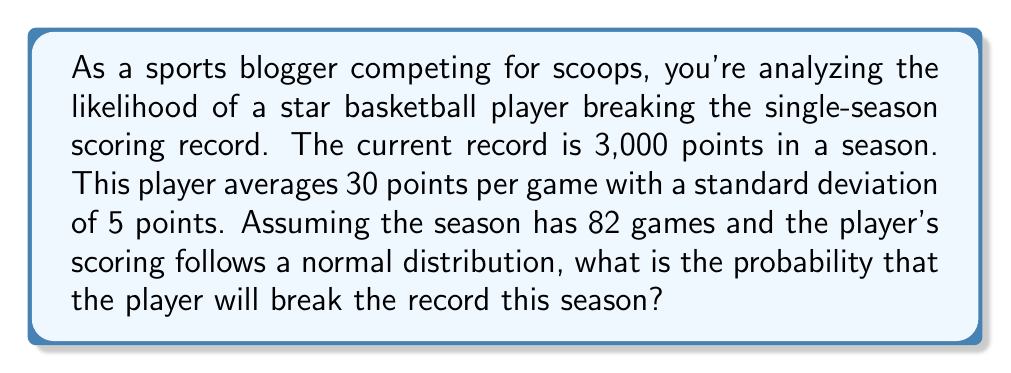Could you help me with this problem? To solve this problem, we need to follow these steps:

1) First, calculate the total points needed to break the record:
   3,000 + 1 = 3,001 points

2) Calculate the mean total points for the season:
   $\mu = 30 \text{ points/game} \times 82 \text{ games} = 2,460 \text{ points}$

3) Calculate the standard deviation for the season:
   $\sigma = 5 \text{ points/game} \times \sqrt{82 \text{ games}} = 45.28 \text{ points}$

4) Calculate the z-score for breaking the record:
   $$z = \frac{x - \mu}{\sigma} = \frac{3001 - 2460}{45.28} = 11.95$$

5) The probability of breaking the record is the area to the right of this z-score on a standard normal distribution.

6) We can use the compliment of the cumulative standard normal distribution function:
   $$P(X > 3001) = 1 - \Phi(11.95)$$

   Where $\Phi$ is the cumulative standard normal distribution function.

7) Using a standard normal table or calculator:
   $$1 - \Phi(11.95) \approx 1 - 0.999999999999 = 1 \times 10^{-12}$$

This extremely small probability indicates that breaking the record is highly unlikely under these conditions.
Answer: The probability of the player breaking the single-season scoring record is approximately $1 \times 10^{-12}$ or 0.0000000001%. 